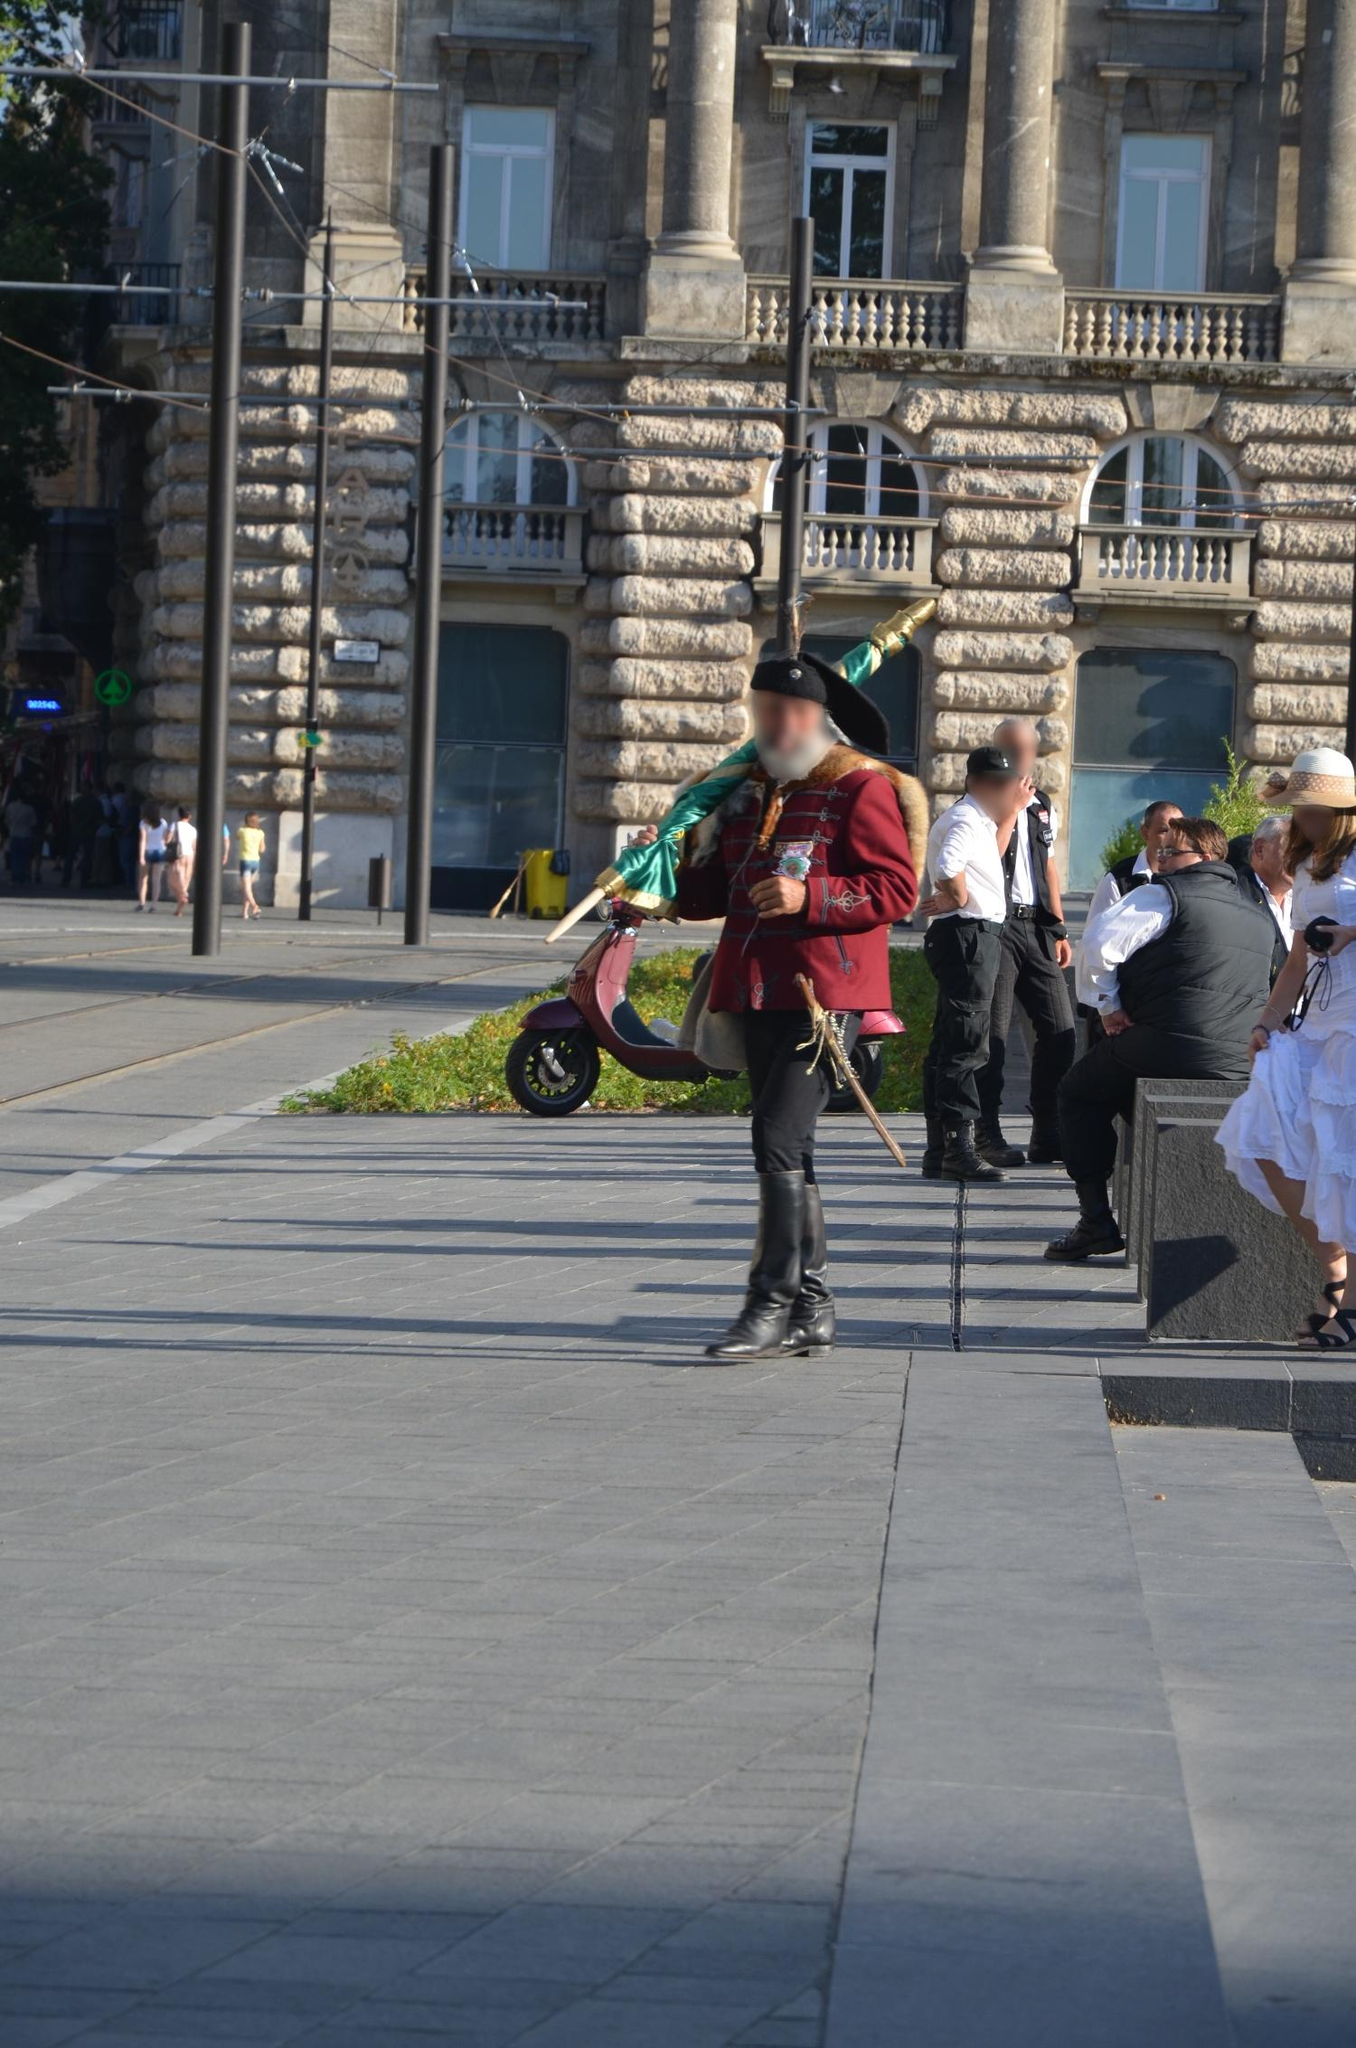What does the interaction of traditional elements with modern surroundings in the image represent? This interaction is a powerful representation of the coexistence and integration of the old with the new. The traditional Hussar uniform against the backdrop of modern urban life in Budapest highlights how historical and cultural elements are preserved and revered even in contemporary settings. This juxtaposition illustrates society's respect for its heritage while embracing modernity, signifying a bridge between the past and the present that fosters a sense of identity and continuity within the community. 